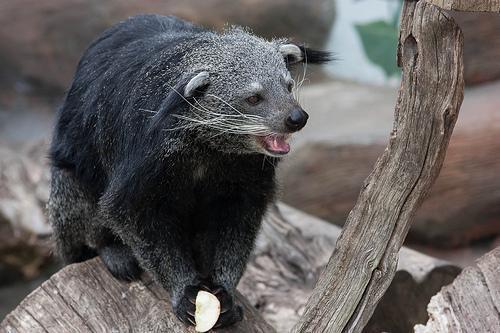How many animals are in the photo?
Give a very brief answer. 1. 